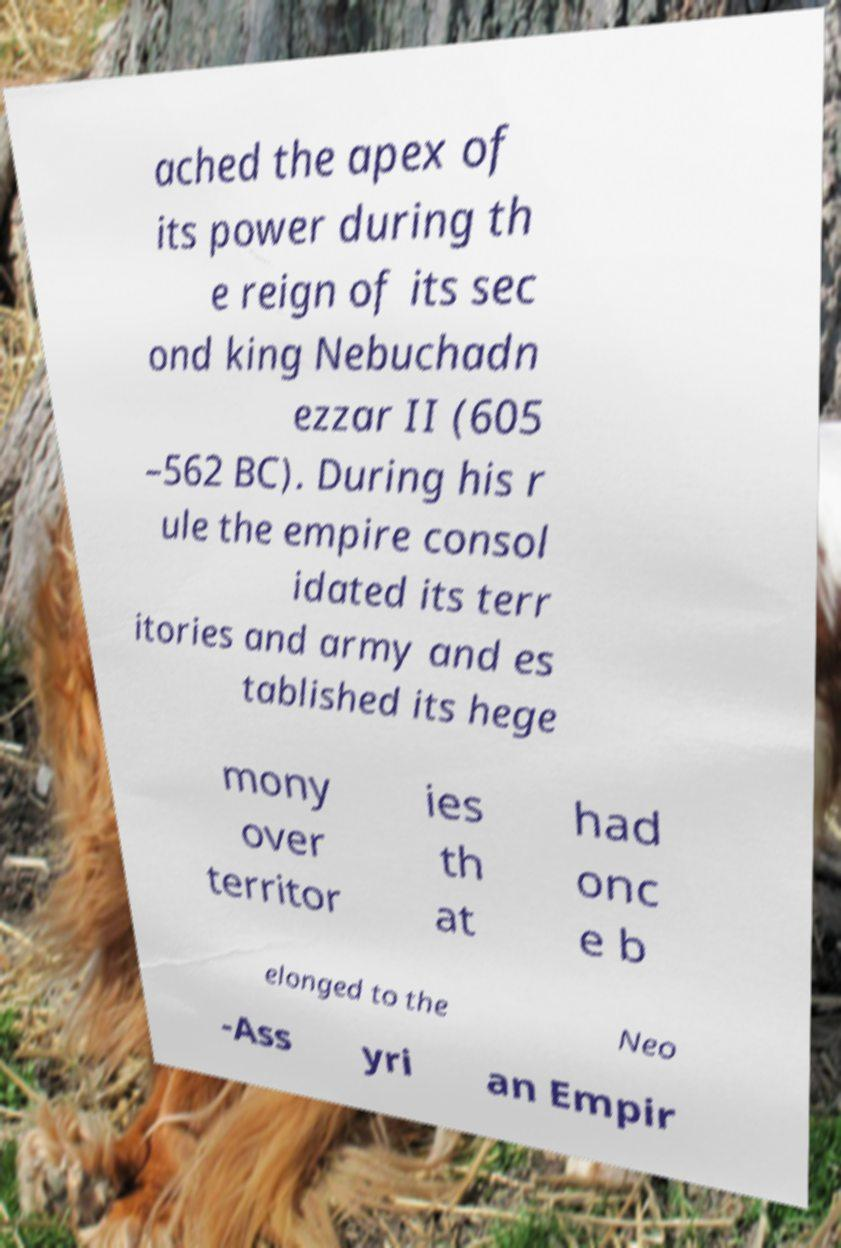Please identify and transcribe the text found in this image. ached the apex of its power during th e reign of its sec ond king Nebuchadn ezzar II (605 –562 BC). During his r ule the empire consol idated its terr itories and army and es tablished its hege mony over territor ies th at had onc e b elonged to the Neo -Ass yri an Empir 